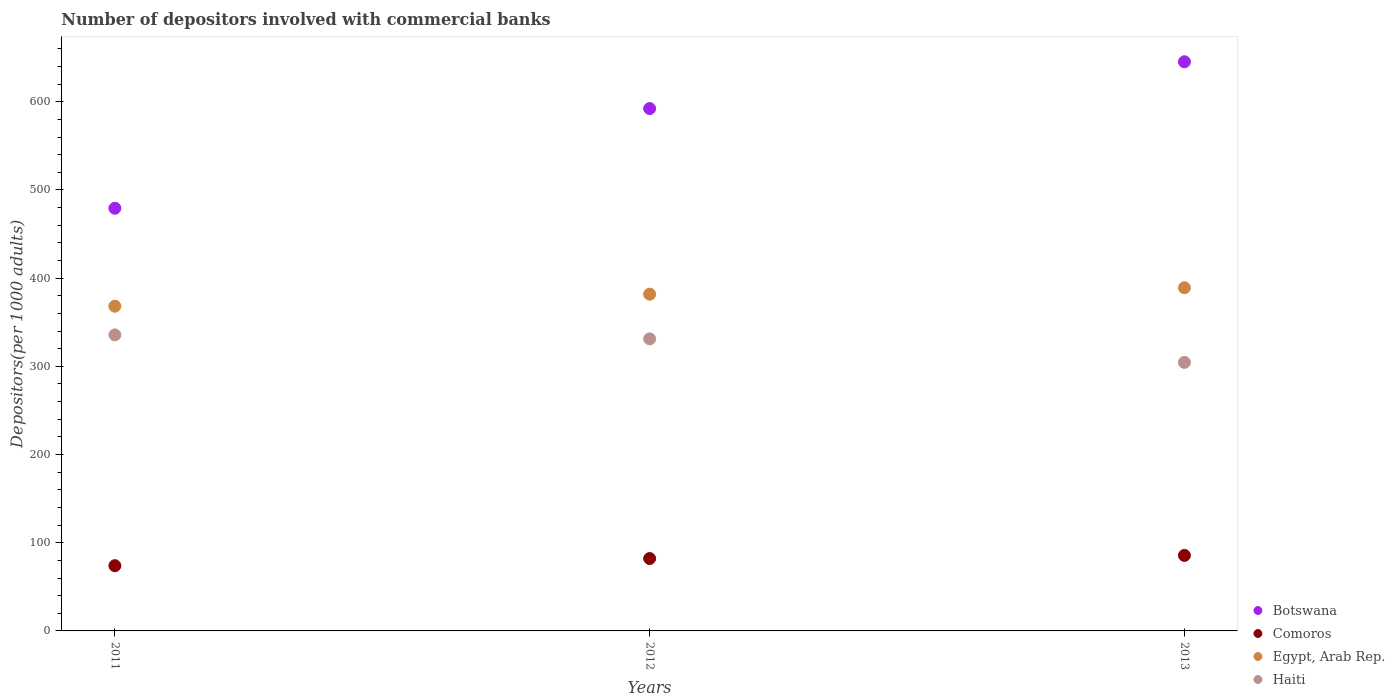Is the number of dotlines equal to the number of legend labels?
Offer a terse response. Yes. What is the number of depositors involved with commercial banks in Botswana in 2013?
Your answer should be compact. 645.33. Across all years, what is the maximum number of depositors involved with commercial banks in Haiti?
Offer a very short reply. 335.67. Across all years, what is the minimum number of depositors involved with commercial banks in Botswana?
Provide a short and direct response. 479.22. What is the total number of depositors involved with commercial banks in Egypt, Arab Rep. in the graph?
Offer a terse response. 1139.13. What is the difference between the number of depositors involved with commercial banks in Botswana in 2011 and that in 2013?
Give a very brief answer. -166.11. What is the difference between the number of depositors involved with commercial banks in Comoros in 2011 and the number of depositors involved with commercial banks in Botswana in 2012?
Ensure brevity in your answer.  -518.3. What is the average number of depositors involved with commercial banks in Comoros per year?
Your response must be concise. 80.56. In the year 2011, what is the difference between the number of depositors involved with commercial banks in Haiti and number of depositors involved with commercial banks in Comoros?
Provide a short and direct response. 261.7. What is the ratio of the number of depositors involved with commercial banks in Haiti in 2011 to that in 2013?
Ensure brevity in your answer.  1.1. Is the number of depositors involved with commercial banks in Botswana in 2011 less than that in 2012?
Your response must be concise. Yes. Is the difference between the number of depositors involved with commercial banks in Haiti in 2011 and 2012 greater than the difference between the number of depositors involved with commercial banks in Comoros in 2011 and 2012?
Your answer should be compact. Yes. What is the difference between the highest and the second highest number of depositors involved with commercial banks in Comoros?
Your answer should be very brief. 3.54. What is the difference between the highest and the lowest number of depositors involved with commercial banks in Comoros?
Offer a terse response. 11.66. Is the sum of the number of depositors involved with commercial banks in Comoros in 2011 and 2012 greater than the maximum number of depositors involved with commercial banks in Egypt, Arab Rep. across all years?
Your response must be concise. No. Is it the case that in every year, the sum of the number of depositors involved with commercial banks in Haiti and number of depositors involved with commercial banks in Egypt, Arab Rep.  is greater than the sum of number of depositors involved with commercial banks in Comoros and number of depositors involved with commercial banks in Botswana?
Offer a very short reply. Yes. How many years are there in the graph?
Offer a terse response. 3. Does the graph contain any zero values?
Your answer should be compact. No. Does the graph contain grids?
Provide a short and direct response. No. How many legend labels are there?
Give a very brief answer. 4. How are the legend labels stacked?
Make the answer very short. Vertical. What is the title of the graph?
Give a very brief answer. Number of depositors involved with commercial banks. Does "Faeroe Islands" appear as one of the legend labels in the graph?
Make the answer very short. No. What is the label or title of the Y-axis?
Your answer should be very brief. Depositors(per 1000 adults). What is the Depositors(per 1000 adults) of Botswana in 2011?
Keep it short and to the point. 479.22. What is the Depositors(per 1000 adults) of Comoros in 2011?
Give a very brief answer. 73.96. What is the Depositors(per 1000 adults) of Egypt, Arab Rep. in 2011?
Provide a succinct answer. 368.19. What is the Depositors(per 1000 adults) in Haiti in 2011?
Provide a succinct answer. 335.67. What is the Depositors(per 1000 adults) of Botswana in 2012?
Your answer should be compact. 592.26. What is the Depositors(per 1000 adults) of Comoros in 2012?
Provide a succinct answer. 82.09. What is the Depositors(per 1000 adults) in Egypt, Arab Rep. in 2012?
Your answer should be compact. 381.83. What is the Depositors(per 1000 adults) of Haiti in 2012?
Make the answer very short. 331.14. What is the Depositors(per 1000 adults) in Botswana in 2013?
Keep it short and to the point. 645.33. What is the Depositors(per 1000 adults) of Comoros in 2013?
Your answer should be very brief. 85.63. What is the Depositors(per 1000 adults) in Egypt, Arab Rep. in 2013?
Provide a succinct answer. 389.11. What is the Depositors(per 1000 adults) in Haiti in 2013?
Provide a succinct answer. 304.48. Across all years, what is the maximum Depositors(per 1000 adults) of Botswana?
Ensure brevity in your answer.  645.33. Across all years, what is the maximum Depositors(per 1000 adults) of Comoros?
Give a very brief answer. 85.63. Across all years, what is the maximum Depositors(per 1000 adults) of Egypt, Arab Rep.?
Your response must be concise. 389.11. Across all years, what is the maximum Depositors(per 1000 adults) in Haiti?
Provide a short and direct response. 335.67. Across all years, what is the minimum Depositors(per 1000 adults) in Botswana?
Your response must be concise. 479.22. Across all years, what is the minimum Depositors(per 1000 adults) in Comoros?
Your answer should be very brief. 73.96. Across all years, what is the minimum Depositors(per 1000 adults) of Egypt, Arab Rep.?
Make the answer very short. 368.19. Across all years, what is the minimum Depositors(per 1000 adults) in Haiti?
Your answer should be very brief. 304.48. What is the total Depositors(per 1000 adults) of Botswana in the graph?
Keep it short and to the point. 1716.81. What is the total Depositors(per 1000 adults) of Comoros in the graph?
Provide a succinct answer. 241.69. What is the total Depositors(per 1000 adults) of Egypt, Arab Rep. in the graph?
Keep it short and to the point. 1139.13. What is the total Depositors(per 1000 adults) of Haiti in the graph?
Offer a terse response. 971.28. What is the difference between the Depositors(per 1000 adults) of Botswana in 2011 and that in 2012?
Your answer should be very brief. -113.04. What is the difference between the Depositors(per 1000 adults) of Comoros in 2011 and that in 2012?
Provide a short and direct response. -8.13. What is the difference between the Depositors(per 1000 adults) in Egypt, Arab Rep. in 2011 and that in 2012?
Keep it short and to the point. -13.63. What is the difference between the Depositors(per 1000 adults) in Haiti in 2011 and that in 2012?
Your response must be concise. 4.53. What is the difference between the Depositors(per 1000 adults) in Botswana in 2011 and that in 2013?
Ensure brevity in your answer.  -166.11. What is the difference between the Depositors(per 1000 adults) of Comoros in 2011 and that in 2013?
Provide a succinct answer. -11.66. What is the difference between the Depositors(per 1000 adults) in Egypt, Arab Rep. in 2011 and that in 2013?
Ensure brevity in your answer.  -20.91. What is the difference between the Depositors(per 1000 adults) in Haiti in 2011 and that in 2013?
Your answer should be compact. 31.19. What is the difference between the Depositors(per 1000 adults) of Botswana in 2012 and that in 2013?
Keep it short and to the point. -53.07. What is the difference between the Depositors(per 1000 adults) of Comoros in 2012 and that in 2013?
Ensure brevity in your answer.  -3.54. What is the difference between the Depositors(per 1000 adults) of Egypt, Arab Rep. in 2012 and that in 2013?
Offer a very short reply. -7.28. What is the difference between the Depositors(per 1000 adults) in Haiti in 2012 and that in 2013?
Give a very brief answer. 26.66. What is the difference between the Depositors(per 1000 adults) of Botswana in 2011 and the Depositors(per 1000 adults) of Comoros in 2012?
Your answer should be very brief. 397.13. What is the difference between the Depositors(per 1000 adults) of Botswana in 2011 and the Depositors(per 1000 adults) of Egypt, Arab Rep. in 2012?
Your answer should be very brief. 97.4. What is the difference between the Depositors(per 1000 adults) of Botswana in 2011 and the Depositors(per 1000 adults) of Haiti in 2012?
Make the answer very short. 148.09. What is the difference between the Depositors(per 1000 adults) of Comoros in 2011 and the Depositors(per 1000 adults) of Egypt, Arab Rep. in 2012?
Offer a very short reply. -307.86. What is the difference between the Depositors(per 1000 adults) of Comoros in 2011 and the Depositors(per 1000 adults) of Haiti in 2012?
Keep it short and to the point. -257.17. What is the difference between the Depositors(per 1000 adults) of Egypt, Arab Rep. in 2011 and the Depositors(per 1000 adults) of Haiti in 2012?
Your response must be concise. 37.06. What is the difference between the Depositors(per 1000 adults) in Botswana in 2011 and the Depositors(per 1000 adults) in Comoros in 2013?
Provide a succinct answer. 393.59. What is the difference between the Depositors(per 1000 adults) in Botswana in 2011 and the Depositors(per 1000 adults) in Egypt, Arab Rep. in 2013?
Give a very brief answer. 90.12. What is the difference between the Depositors(per 1000 adults) in Botswana in 2011 and the Depositors(per 1000 adults) in Haiti in 2013?
Ensure brevity in your answer.  174.74. What is the difference between the Depositors(per 1000 adults) of Comoros in 2011 and the Depositors(per 1000 adults) of Egypt, Arab Rep. in 2013?
Your answer should be very brief. -315.14. What is the difference between the Depositors(per 1000 adults) of Comoros in 2011 and the Depositors(per 1000 adults) of Haiti in 2013?
Your answer should be compact. -230.51. What is the difference between the Depositors(per 1000 adults) of Egypt, Arab Rep. in 2011 and the Depositors(per 1000 adults) of Haiti in 2013?
Ensure brevity in your answer.  63.72. What is the difference between the Depositors(per 1000 adults) of Botswana in 2012 and the Depositors(per 1000 adults) of Comoros in 2013?
Your answer should be very brief. 506.63. What is the difference between the Depositors(per 1000 adults) in Botswana in 2012 and the Depositors(per 1000 adults) in Egypt, Arab Rep. in 2013?
Keep it short and to the point. 203.16. What is the difference between the Depositors(per 1000 adults) in Botswana in 2012 and the Depositors(per 1000 adults) in Haiti in 2013?
Offer a terse response. 287.78. What is the difference between the Depositors(per 1000 adults) of Comoros in 2012 and the Depositors(per 1000 adults) of Egypt, Arab Rep. in 2013?
Ensure brevity in your answer.  -307.01. What is the difference between the Depositors(per 1000 adults) of Comoros in 2012 and the Depositors(per 1000 adults) of Haiti in 2013?
Your answer should be compact. -222.39. What is the difference between the Depositors(per 1000 adults) in Egypt, Arab Rep. in 2012 and the Depositors(per 1000 adults) in Haiti in 2013?
Your answer should be very brief. 77.35. What is the average Depositors(per 1000 adults) in Botswana per year?
Ensure brevity in your answer.  572.27. What is the average Depositors(per 1000 adults) in Comoros per year?
Make the answer very short. 80.56. What is the average Depositors(per 1000 adults) of Egypt, Arab Rep. per year?
Keep it short and to the point. 379.71. What is the average Depositors(per 1000 adults) in Haiti per year?
Make the answer very short. 323.76. In the year 2011, what is the difference between the Depositors(per 1000 adults) of Botswana and Depositors(per 1000 adults) of Comoros?
Keep it short and to the point. 405.26. In the year 2011, what is the difference between the Depositors(per 1000 adults) in Botswana and Depositors(per 1000 adults) in Egypt, Arab Rep.?
Keep it short and to the point. 111.03. In the year 2011, what is the difference between the Depositors(per 1000 adults) in Botswana and Depositors(per 1000 adults) in Haiti?
Your response must be concise. 143.55. In the year 2011, what is the difference between the Depositors(per 1000 adults) in Comoros and Depositors(per 1000 adults) in Egypt, Arab Rep.?
Offer a very short reply. -294.23. In the year 2011, what is the difference between the Depositors(per 1000 adults) in Comoros and Depositors(per 1000 adults) in Haiti?
Your answer should be very brief. -261.7. In the year 2011, what is the difference between the Depositors(per 1000 adults) in Egypt, Arab Rep. and Depositors(per 1000 adults) in Haiti?
Offer a very short reply. 32.52. In the year 2012, what is the difference between the Depositors(per 1000 adults) of Botswana and Depositors(per 1000 adults) of Comoros?
Keep it short and to the point. 510.17. In the year 2012, what is the difference between the Depositors(per 1000 adults) in Botswana and Depositors(per 1000 adults) in Egypt, Arab Rep.?
Offer a very short reply. 210.44. In the year 2012, what is the difference between the Depositors(per 1000 adults) in Botswana and Depositors(per 1000 adults) in Haiti?
Make the answer very short. 261.12. In the year 2012, what is the difference between the Depositors(per 1000 adults) in Comoros and Depositors(per 1000 adults) in Egypt, Arab Rep.?
Offer a very short reply. -299.74. In the year 2012, what is the difference between the Depositors(per 1000 adults) of Comoros and Depositors(per 1000 adults) of Haiti?
Offer a very short reply. -249.05. In the year 2012, what is the difference between the Depositors(per 1000 adults) in Egypt, Arab Rep. and Depositors(per 1000 adults) in Haiti?
Provide a succinct answer. 50.69. In the year 2013, what is the difference between the Depositors(per 1000 adults) in Botswana and Depositors(per 1000 adults) in Comoros?
Offer a very short reply. 559.7. In the year 2013, what is the difference between the Depositors(per 1000 adults) of Botswana and Depositors(per 1000 adults) of Egypt, Arab Rep.?
Give a very brief answer. 256.22. In the year 2013, what is the difference between the Depositors(per 1000 adults) in Botswana and Depositors(per 1000 adults) in Haiti?
Your answer should be compact. 340.85. In the year 2013, what is the difference between the Depositors(per 1000 adults) in Comoros and Depositors(per 1000 adults) in Egypt, Arab Rep.?
Your response must be concise. -303.48. In the year 2013, what is the difference between the Depositors(per 1000 adults) in Comoros and Depositors(per 1000 adults) in Haiti?
Your response must be concise. -218.85. In the year 2013, what is the difference between the Depositors(per 1000 adults) of Egypt, Arab Rep. and Depositors(per 1000 adults) of Haiti?
Your answer should be compact. 84.63. What is the ratio of the Depositors(per 1000 adults) in Botswana in 2011 to that in 2012?
Offer a terse response. 0.81. What is the ratio of the Depositors(per 1000 adults) of Comoros in 2011 to that in 2012?
Your answer should be very brief. 0.9. What is the ratio of the Depositors(per 1000 adults) of Haiti in 2011 to that in 2012?
Your response must be concise. 1.01. What is the ratio of the Depositors(per 1000 adults) of Botswana in 2011 to that in 2013?
Your answer should be very brief. 0.74. What is the ratio of the Depositors(per 1000 adults) of Comoros in 2011 to that in 2013?
Offer a terse response. 0.86. What is the ratio of the Depositors(per 1000 adults) in Egypt, Arab Rep. in 2011 to that in 2013?
Your answer should be compact. 0.95. What is the ratio of the Depositors(per 1000 adults) in Haiti in 2011 to that in 2013?
Your response must be concise. 1.1. What is the ratio of the Depositors(per 1000 adults) in Botswana in 2012 to that in 2013?
Offer a very short reply. 0.92. What is the ratio of the Depositors(per 1000 adults) of Comoros in 2012 to that in 2013?
Your answer should be very brief. 0.96. What is the ratio of the Depositors(per 1000 adults) of Egypt, Arab Rep. in 2012 to that in 2013?
Your answer should be very brief. 0.98. What is the ratio of the Depositors(per 1000 adults) in Haiti in 2012 to that in 2013?
Provide a short and direct response. 1.09. What is the difference between the highest and the second highest Depositors(per 1000 adults) of Botswana?
Make the answer very short. 53.07. What is the difference between the highest and the second highest Depositors(per 1000 adults) in Comoros?
Ensure brevity in your answer.  3.54. What is the difference between the highest and the second highest Depositors(per 1000 adults) in Egypt, Arab Rep.?
Your answer should be compact. 7.28. What is the difference between the highest and the second highest Depositors(per 1000 adults) in Haiti?
Make the answer very short. 4.53. What is the difference between the highest and the lowest Depositors(per 1000 adults) of Botswana?
Keep it short and to the point. 166.11. What is the difference between the highest and the lowest Depositors(per 1000 adults) in Comoros?
Your answer should be very brief. 11.66. What is the difference between the highest and the lowest Depositors(per 1000 adults) of Egypt, Arab Rep.?
Your answer should be compact. 20.91. What is the difference between the highest and the lowest Depositors(per 1000 adults) in Haiti?
Keep it short and to the point. 31.19. 